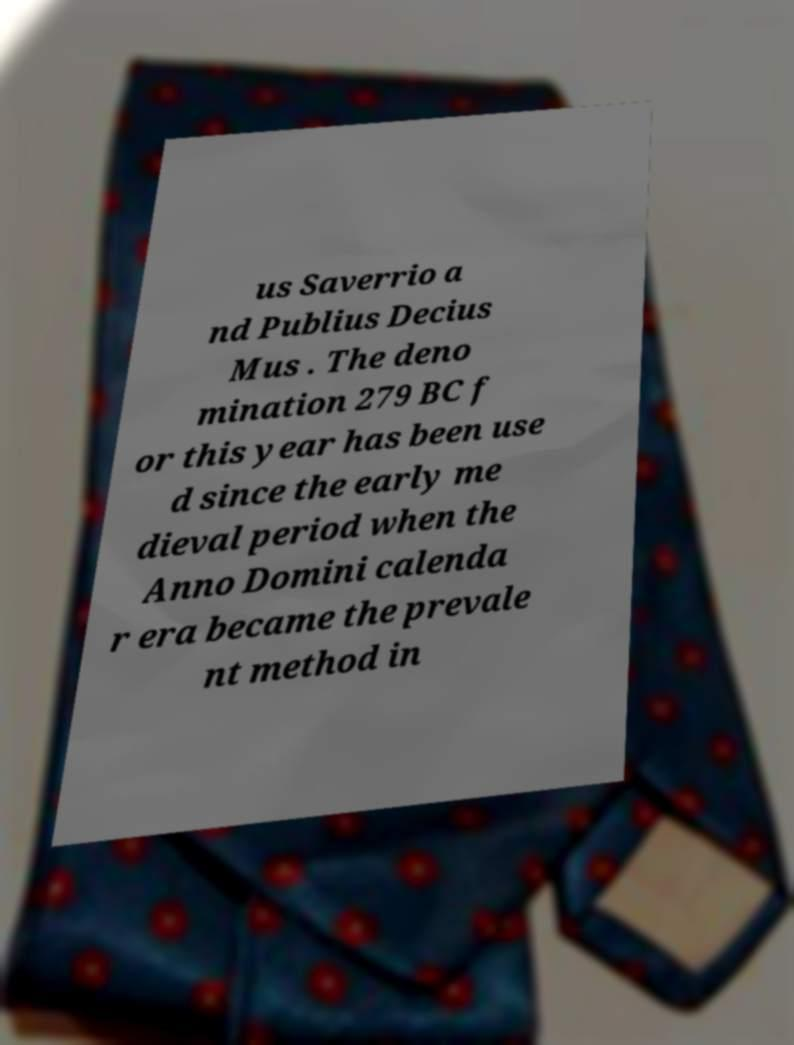Could you assist in decoding the text presented in this image and type it out clearly? us Saverrio a nd Publius Decius Mus . The deno mination 279 BC f or this year has been use d since the early me dieval period when the Anno Domini calenda r era became the prevale nt method in 